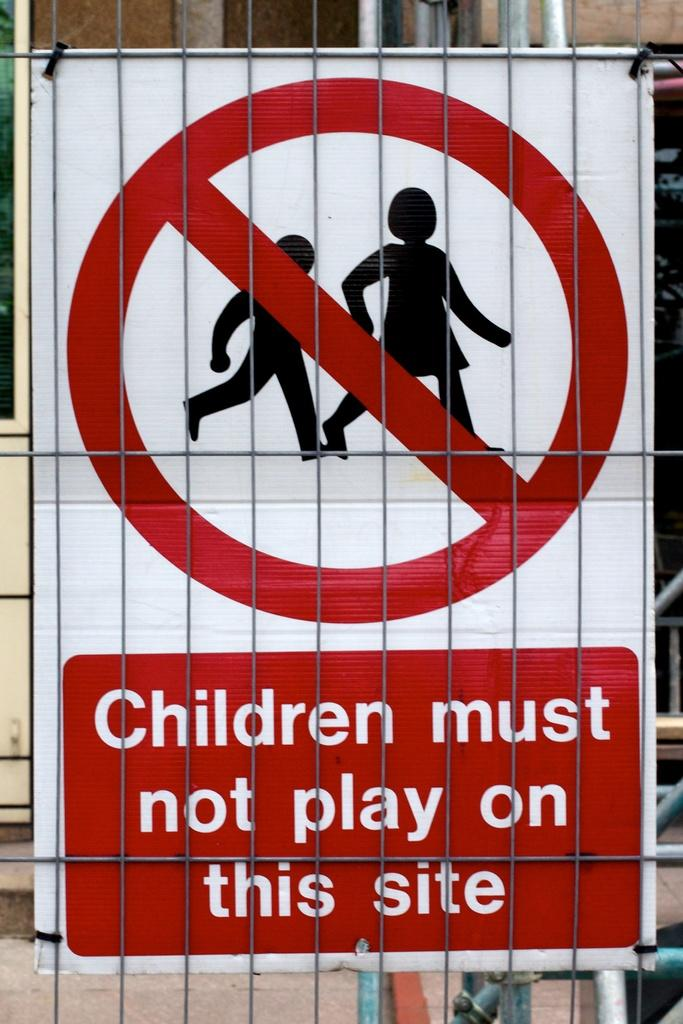<image>
Provide a brief description of the given image. A sign on a fence that reads Children must not play on this side. 